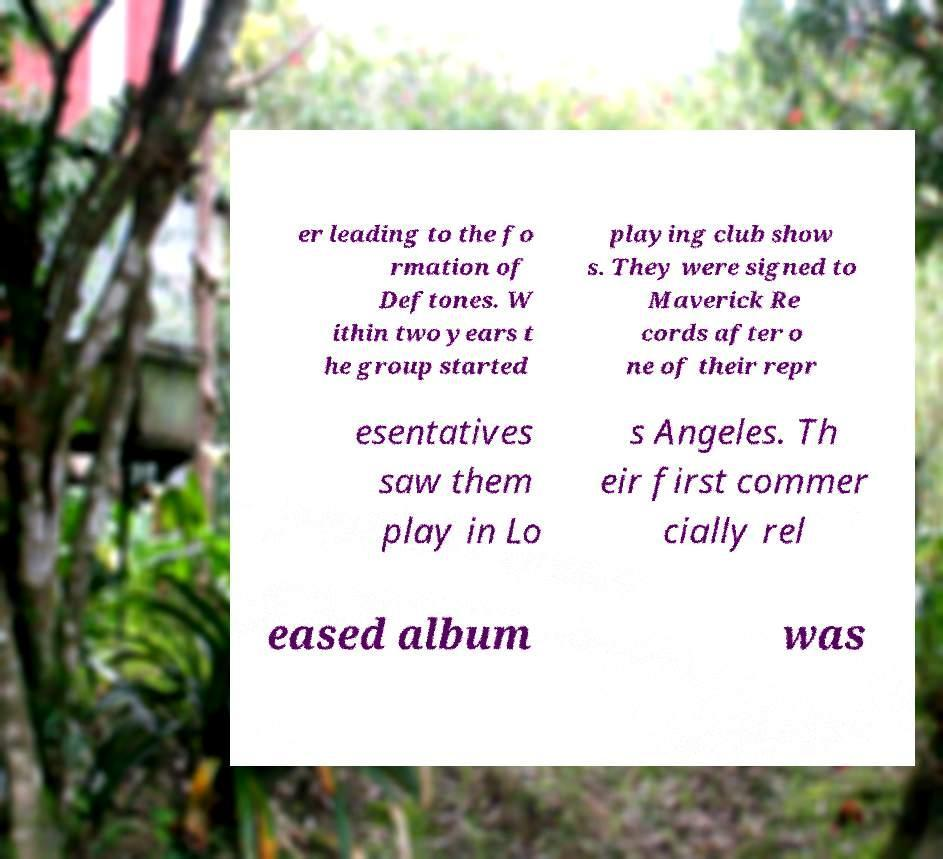Please read and relay the text visible in this image. What does it say? er leading to the fo rmation of Deftones. W ithin two years t he group started playing club show s. They were signed to Maverick Re cords after o ne of their repr esentatives saw them play in Lo s Angeles. Th eir first commer cially rel eased album was 